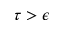Convert formula to latex. <formula><loc_0><loc_0><loc_500><loc_500>\tau > \epsilon</formula> 